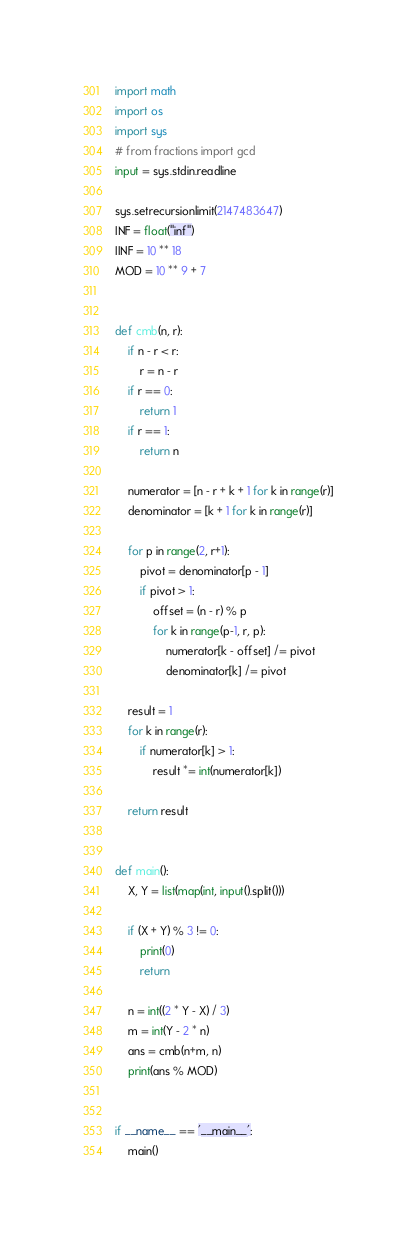Convert code to text. <code><loc_0><loc_0><loc_500><loc_500><_Python_>import math
import os
import sys
# from fractions import gcd
input = sys.stdin.readline

sys.setrecursionlimit(2147483647)
INF = float("inf")
IINF = 10 ** 18
MOD = 10 ** 9 + 7


def cmb(n, r):
    if n - r < r:
        r = n - r
    if r == 0:
        return 1
    if r == 1:
        return n

    numerator = [n - r + k + 1 for k in range(r)]
    denominator = [k + 1 for k in range(r)]

    for p in range(2, r+1):
        pivot = denominator[p - 1]
        if pivot > 1:
            offset = (n - r) % p
            for k in range(p-1, r, p):
                numerator[k - offset] /= pivot
                denominator[k] /= pivot

    result = 1
    for k in range(r):
        if numerator[k] > 1:
            result *= int(numerator[k])

    return result


def main():
    X, Y = list(map(int, input().split()))

    if (X + Y) % 3 != 0:
        print(0)
        return

    n = int((2 * Y - X) / 3)
    m = int(Y - 2 * n)
    ans = cmb(n+m, n)
    print(ans % MOD)


if __name__ == '__main__':
    main()
</code> 